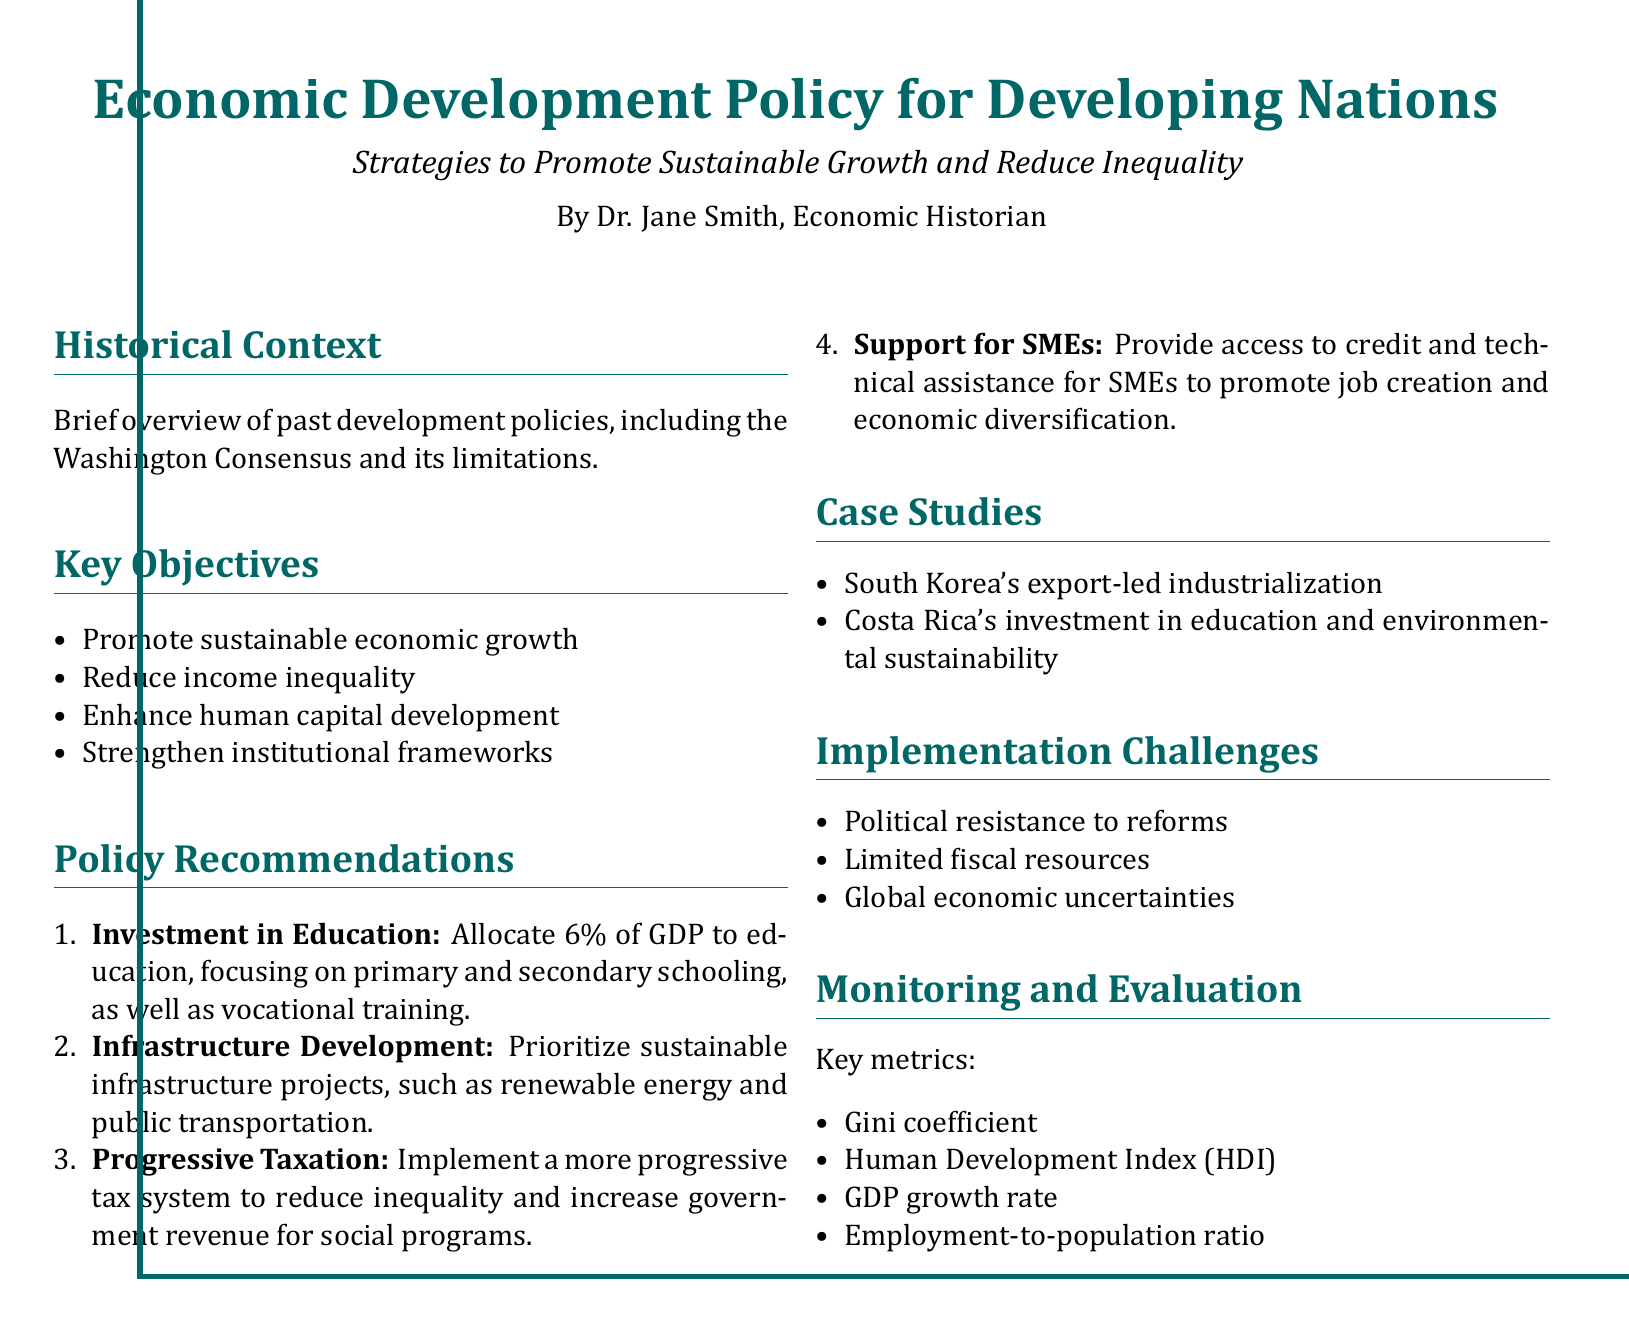What are the key objectives of the policy? The key objectives are listed in the document as specific bullet points outlining the aims of the policy.
Answer: Promote sustainable economic growth, reduce income inequality, enhance human capital development, strengthen institutional frameworks What percentage of GDP should be allocated to education? The document specifies a particular percentage of GDP that should be focused on education as part of the policy recommendations.
Answer: 6 percent What type of taxation is recommended to reduce inequality? The document describes a specific form of taxation that aims to address economic disparity.
Answer: Progressive taxation Which two countries are highlighted in the case studies? The case studies section provides examples of countries that illustrate successful strategies in economic development.
Answer: South Korea, Costa Rica What is one of the implementation challenges mentioned? The document lists several challenges related to executing the policy recommendations, one of which can be identified.
Answer: Political resistance to reforms What key metric is used to measure income inequality? The monitoring and evaluation section identifies different metrics for assessing economic performance and inequality, including a specific one for inequality.
Answer: Gini coefficient 